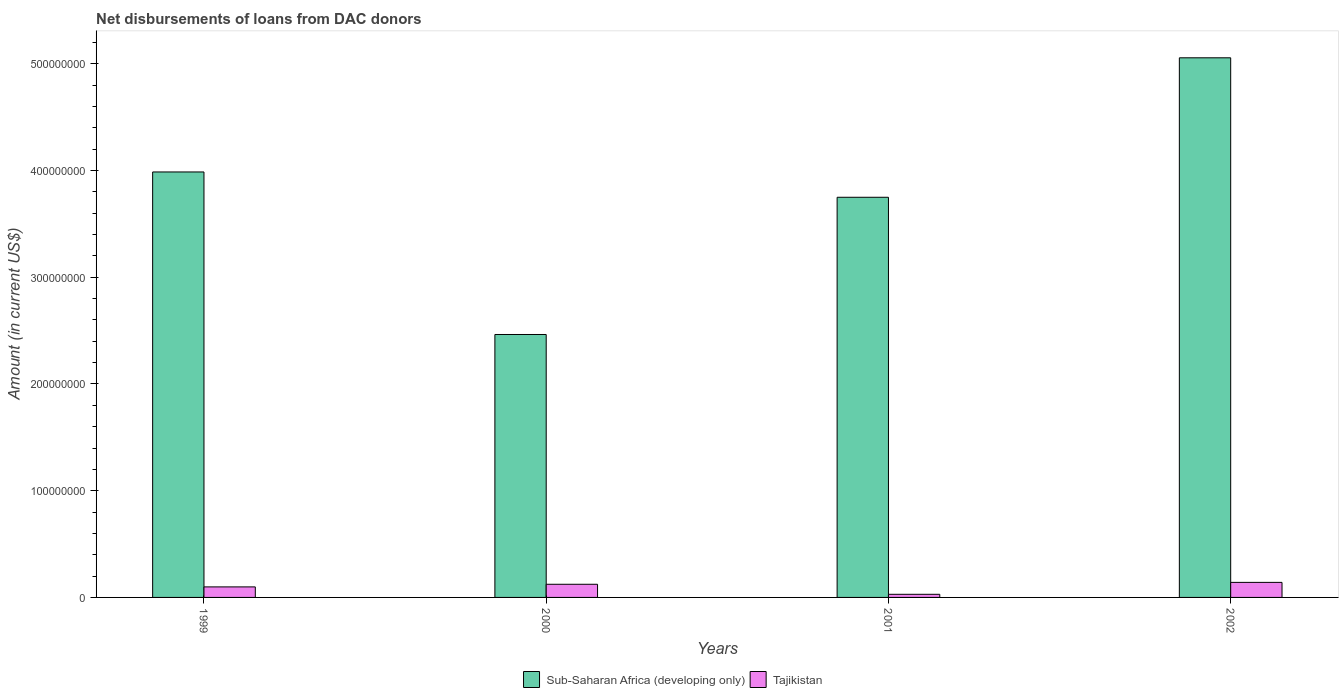How many groups of bars are there?
Give a very brief answer. 4. Are the number of bars on each tick of the X-axis equal?
Provide a succinct answer. Yes. How many bars are there on the 4th tick from the left?
Provide a succinct answer. 2. What is the label of the 3rd group of bars from the left?
Ensure brevity in your answer.  2001. In how many cases, is the number of bars for a given year not equal to the number of legend labels?
Offer a terse response. 0. What is the amount of loans disbursed in Sub-Saharan Africa (developing only) in 2001?
Your answer should be very brief. 3.75e+08. Across all years, what is the maximum amount of loans disbursed in Tajikistan?
Your response must be concise. 1.41e+07. Across all years, what is the minimum amount of loans disbursed in Tajikistan?
Make the answer very short. 2.93e+06. In which year was the amount of loans disbursed in Tajikistan maximum?
Offer a very short reply. 2002. In which year was the amount of loans disbursed in Sub-Saharan Africa (developing only) minimum?
Your answer should be very brief. 2000. What is the total amount of loans disbursed in Sub-Saharan Africa (developing only) in the graph?
Offer a terse response. 1.53e+09. What is the difference between the amount of loans disbursed in Tajikistan in 1999 and that in 2000?
Your answer should be very brief. -2.46e+06. What is the difference between the amount of loans disbursed in Sub-Saharan Africa (developing only) in 2001 and the amount of loans disbursed in Tajikistan in 2002?
Provide a short and direct response. 3.61e+08. What is the average amount of loans disbursed in Sub-Saharan Africa (developing only) per year?
Make the answer very short. 3.81e+08. In the year 1999, what is the difference between the amount of loans disbursed in Tajikistan and amount of loans disbursed in Sub-Saharan Africa (developing only)?
Your response must be concise. -3.89e+08. What is the ratio of the amount of loans disbursed in Tajikistan in 1999 to that in 2001?
Provide a short and direct response. 3.37. Is the amount of loans disbursed in Sub-Saharan Africa (developing only) in 1999 less than that in 2001?
Offer a very short reply. No. What is the difference between the highest and the second highest amount of loans disbursed in Tajikistan?
Provide a short and direct response. 1.78e+06. What is the difference between the highest and the lowest amount of loans disbursed in Tajikistan?
Give a very brief answer. 1.12e+07. In how many years, is the amount of loans disbursed in Tajikistan greater than the average amount of loans disbursed in Tajikistan taken over all years?
Keep it short and to the point. 3. Is the sum of the amount of loans disbursed in Sub-Saharan Africa (developing only) in 2000 and 2002 greater than the maximum amount of loans disbursed in Tajikistan across all years?
Make the answer very short. Yes. What does the 1st bar from the left in 2000 represents?
Ensure brevity in your answer.  Sub-Saharan Africa (developing only). What does the 1st bar from the right in 2002 represents?
Keep it short and to the point. Tajikistan. How many years are there in the graph?
Your answer should be very brief. 4. Does the graph contain any zero values?
Give a very brief answer. No. Where does the legend appear in the graph?
Give a very brief answer. Bottom center. How many legend labels are there?
Keep it short and to the point. 2. How are the legend labels stacked?
Offer a terse response. Horizontal. What is the title of the graph?
Keep it short and to the point. Net disbursements of loans from DAC donors. Does "Ireland" appear as one of the legend labels in the graph?
Give a very brief answer. No. What is the label or title of the Y-axis?
Your response must be concise. Amount (in current US$). What is the Amount (in current US$) in Sub-Saharan Africa (developing only) in 1999?
Ensure brevity in your answer.  3.99e+08. What is the Amount (in current US$) of Tajikistan in 1999?
Your answer should be very brief. 9.87e+06. What is the Amount (in current US$) in Sub-Saharan Africa (developing only) in 2000?
Keep it short and to the point. 2.46e+08. What is the Amount (in current US$) of Tajikistan in 2000?
Provide a short and direct response. 1.23e+07. What is the Amount (in current US$) of Sub-Saharan Africa (developing only) in 2001?
Offer a very short reply. 3.75e+08. What is the Amount (in current US$) in Tajikistan in 2001?
Your response must be concise. 2.93e+06. What is the Amount (in current US$) of Sub-Saharan Africa (developing only) in 2002?
Your response must be concise. 5.06e+08. What is the Amount (in current US$) in Tajikistan in 2002?
Offer a very short reply. 1.41e+07. Across all years, what is the maximum Amount (in current US$) of Sub-Saharan Africa (developing only)?
Offer a terse response. 5.06e+08. Across all years, what is the maximum Amount (in current US$) of Tajikistan?
Your response must be concise. 1.41e+07. Across all years, what is the minimum Amount (in current US$) in Sub-Saharan Africa (developing only)?
Offer a very short reply. 2.46e+08. Across all years, what is the minimum Amount (in current US$) of Tajikistan?
Keep it short and to the point. 2.93e+06. What is the total Amount (in current US$) in Sub-Saharan Africa (developing only) in the graph?
Provide a succinct answer. 1.53e+09. What is the total Amount (in current US$) in Tajikistan in the graph?
Make the answer very short. 3.92e+07. What is the difference between the Amount (in current US$) in Sub-Saharan Africa (developing only) in 1999 and that in 2000?
Offer a terse response. 1.52e+08. What is the difference between the Amount (in current US$) of Tajikistan in 1999 and that in 2000?
Ensure brevity in your answer.  -2.46e+06. What is the difference between the Amount (in current US$) of Sub-Saharan Africa (developing only) in 1999 and that in 2001?
Offer a very short reply. 2.37e+07. What is the difference between the Amount (in current US$) in Tajikistan in 1999 and that in 2001?
Offer a terse response. 6.94e+06. What is the difference between the Amount (in current US$) in Sub-Saharan Africa (developing only) in 1999 and that in 2002?
Offer a very short reply. -1.07e+08. What is the difference between the Amount (in current US$) of Tajikistan in 1999 and that in 2002?
Your answer should be compact. -4.23e+06. What is the difference between the Amount (in current US$) in Sub-Saharan Africa (developing only) in 2000 and that in 2001?
Offer a very short reply. -1.29e+08. What is the difference between the Amount (in current US$) in Tajikistan in 2000 and that in 2001?
Keep it short and to the point. 9.40e+06. What is the difference between the Amount (in current US$) of Sub-Saharan Africa (developing only) in 2000 and that in 2002?
Provide a succinct answer. -2.59e+08. What is the difference between the Amount (in current US$) of Tajikistan in 2000 and that in 2002?
Make the answer very short. -1.78e+06. What is the difference between the Amount (in current US$) in Sub-Saharan Africa (developing only) in 2001 and that in 2002?
Provide a succinct answer. -1.31e+08. What is the difference between the Amount (in current US$) in Tajikistan in 2001 and that in 2002?
Provide a short and direct response. -1.12e+07. What is the difference between the Amount (in current US$) of Sub-Saharan Africa (developing only) in 1999 and the Amount (in current US$) of Tajikistan in 2000?
Offer a very short reply. 3.86e+08. What is the difference between the Amount (in current US$) of Sub-Saharan Africa (developing only) in 1999 and the Amount (in current US$) of Tajikistan in 2001?
Make the answer very short. 3.96e+08. What is the difference between the Amount (in current US$) of Sub-Saharan Africa (developing only) in 1999 and the Amount (in current US$) of Tajikistan in 2002?
Your answer should be compact. 3.85e+08. What is the difference between the Amount (in current US$) in Sub-Saharan Africa (developing only) in 2000 and the Amount (in current US$) in Tajikistan in 2001?
Provide a succinct answer. 2.43e+08. What is the difference between the Amount (in current US$) of Sub-Saharan Africa (developing only) in 2000 and the Amount (in current US$) of Tajikistan in 2002?
Provide a succinct answer. 2.32e+08. What is the difference between the Amount (in current US$) of Sub-Saharan Africa (developing only) in 2001 and the Amount (in current US$) of Tajikistan in 2002?
Give a very brief answer. 3.61e+08. What is the average Amount (in current US$) in Sub-Saharan Africa (developing only) per year?
Your response must be concise. 3.81e+08. What is the average Amount (in current US$) in Tajikistan per year?
Your answer should be very brief. 9.80e+06. In the year 1999, what is the difference between the Amount (in current US$) in Sub-Saharan Africa (developing only) and Amount (in current US$) in Tajikistan?
Your response must be concise. 3.89e+08. In the year 2000, what is the difference between the Amount (in current US$) of Sub-Saharan Africa (developing only) and Amount (in current US$) of Tajikistan?
Offer a very short reply. 2.34e+08. In the year 2001, what is the difference between the Amount (in current US$) of Sub-Saharan Africa (developing only) and Amount (in current US$) of Tajikistan?
Your response must be concise. 3.72e+08. In the year 2002, what is the difference between the Amount (in current US$) in Sub-Saharan Africa (developing only) and Amount (in current US$) in Tajikistan?
Offer a very short reply. 4.92e+08. What is the ratio of the Amount (in current US$) of Sub-Saharan Africa (developing only) in 1999 to that in 2000?
Make the answer very short. 1.62. What is the ratio of the Amount (in current US$) in Tajikistan in 1999 to that in 2000?
Your answer should be compact. 0.8. What is the ratio of the Amount (in current US$) in Sub-Saharan Africa (developing only) in 1999 to that in 2001?
Offer a terse response. 1.06. What is the ratio of the Amount (in current US$) in Tajikistan in 1999 to that in 2001?
Provide a succinct answer. 3.37. What is the ratio of the Amount (in current US$) in Sub-Saharan Africa (developing only) in 1999 to that in 2002?
Make the answer very short. 0.79. What is the ratio of the Amount (in current US$) in Tajikistan in 1999 to that in 2002?
Your response must be concise. 0.7. What is the ratio of the Amount (in current US$) in Sub-Saharan Africa (developing only) in 2000 to that in 2001?
Your response must be concise. 0.66. What is the ratio of the Amount (in current US$) of Tajikistan in 2000 to that in 2001?
Your response must be concise. 4.21. What is the ratio of the Amount (in current US$) in Sub-Saharan Africa (developing only) in 2000 to that in 2002?
Give a very brief answer. 0.49. What is the ratio of the Amount (in current US$) of Tajikistan in 2000 to that in 2002?
Ensure brevity in your answer.  0.87. What is the ratio of the Amount (in current US$) in Sub-Saharan Africa (developing only) in 2001 to that in 2002?
Provide a succinct answer. 0.74. What is the ratio of the Amount (in current US$) of Tajikistan in 2001 to that in 2002?
Give a very brief answer. 0.21. What is the difference between the highest and the second highest Amount (in current US$) of Sub-Saharan Africa (developing only)?
Your response must be concise. 1.07e+08. What is the difference between the highest and the second highest Amount (in current US$) of Tajikistan?
Keep it short and to the point. 1.78e+06. What is the difference between the highest and the lowest Amount (in current US$) of Sub-Saharan Africa (developing only)?
Provide a short and direct response. 2.59e+08. What is the difference between the highest and the lowest Amount (in current US$) of Tajikistan?
Your answer should be compact. 1.12e+07. 